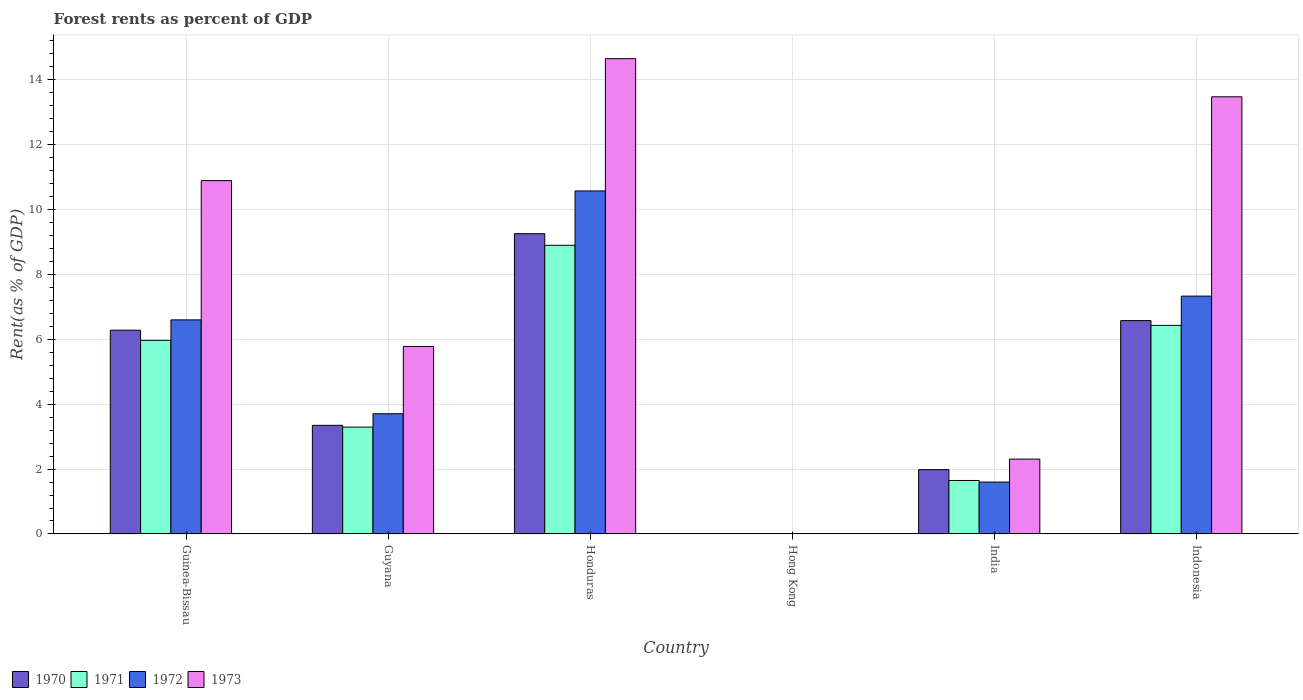How many different coloured bars are there?
Ensure brevity in your answer.  4. How many groups of bars are there?
Your answer should be very brief. 6. Are the number of bars per tick equal to the number of legend labels?
Ensure brevity in your answer.  Yes. How many bars are there on the 3rd tick from the right?
Provide a succinct answer. 4. What is the label of the 1st group of bars from the left?
Offer a terse response. Guinea-Bissau. In how many cases, is the number of bars for a given country not equal to the number of legend labels?
Keep it short and to the point. 0. What is the forest rent in 1973 in Honduras?
Ensure brevity in your answer.  14.64. Across all countries, what is the maximum forest rent in 1971?
Your answer should be very brief. 8.89. Across all countries, what is the minimum forest rent in 1970?
Offer a very short reply. 0.01. In which country was the forest rent in 1970 maximum?
Your response must be concise. Honduras. In which country was the forest rent in 1970 minimum?
Make the answer very short. Hong Kong. What is the total forest rent in 1970 in the graph?
Make the answer very short. 27.44. What is the difference between the forest rent in 1971 in Guinea-Bissau and that in Honduras?
Your response must be concise. -2.93. What is the difference between the forest rent in 1973 in Guyana and the forest rent in 1971 in Honduras?
Your answer should be very brief. -3.12. What is the average forest rent in 1970 per country?
Make the answer very short. 4.57. What is the difference between the forest rent of/in 1971 and forest rent of/in 1972 in Hong Kong?
Keep it short and to the point. 0. What is the ratio of the forest rent in 1972 in Guyana to that in India?
Make the answer very short. 2.32. Is the forest rent in 1970 in Honduras less than that in India?
Provide a succinct answer. No. Is the difference between the forest rent in 1971 in India and Indonesia greater than the difference between the forest rent in 1972 in India and Indonesia?
Keep it short and to the point. Yes. What is the difference between the highest and the second highest forest rent in 1973?
Provide a short and direct response. -2.58. What is the difference between the highest and the lowest forest rent in 1971?
Your answer should be very brief. 8.89. In how many countries, is the forest rent in 1970 greater than the average forest rent in 1970 taken over all countries?
Offer a very short reply. 3. Is it the case that in every country, the sum of the forest rent in 1972 and forest rent in 1970 is greater than the forest rent in 1971?
Your answer should be very brief. Yes. How many bars are there?
Provide a succinct answer. 24. Are all the bars in the graph horizontal?
Your response must be concise. No. How many countries are there in the graph?
Provide a short and direct response. 6. Are the values on the major ticks of Y-axis written in scientific E-notation?
Provide a succinct answer. No. Does the graph contain grids?
Offer a very short reply. Yes. How many legend labels are there?
Your response must be concise. 4. What is the title of the graph?
Offer a terse response. Forest rents as percent of GDP. Does "2010" appear as one of the legend labels in the graph?
Keep it short and to the point. No. What is the label or title of the Y-axis?
Your response must be concise. Rent(as % of GDP). What is the Rent(as % of GDP) in 1970 in Guinea-Bissau?
Your response must be concise. 6.28. What is the Rent(as % of GDP) in 1971 in Guinea-Bissau?
Give a very brief answer. 5.97. What is the Rent(as % of GDP) of 1972 in Guinea-Bissau?
Offer a very short reply. 6.6. What is the Rent(as % of GDP) in 1973 in Guinea-Bissau?
Make the answer very short. 10.89. What is the Rent(as % of GDP) in 1970 in Guyana?
Offer a terse response. 3.35. What is the Rent(as % of GDP) in 1971 in Guyana?
Offer a terse response. 3.29. What is the Rent(as % of GDP) in 1972 in Guyana?
Provide a succinct answer. 3.7. What is the Rent(as % of GDP) in 1973 in Guyana?
Provide a succinct answer. 5.78. What is the Rent(as % of GDP) of 1970 in Honduras?
Your answer should be very brief. 9.25. What is the Rent(as % of GDP) of 1971 in Honduras?
Offer a terse response. 8.89. What is the Rent(as % of GDP) in 1972 in Honduras?
Offer a terse response. 10.57. What is the Rent(as % of GDP) of 1973 in Honduras?
Ensure brevity in your answer.  14.64. What is the Rent(as % of GDP) of 1970 in Hong Kong?
Make the answer very short. 0.01. What is the Rent(as % of GDP) of 1971 in Hong Kong?
Your answer should be very brief. 0.01. What is the Rent(as % of GDP) in 1972 in Hong Kong?
Offer a very short reply. 0.01. What is the Rent(as % of GDP) of 1973 in Hong Kong?
Offer a very short reply. 0.01. What is the Rent(as % of GDP) in 1970 in India?
Ensure brevity in your answer.  1.98. What is the Rent(as % of GDP) of 1971 in India?
Provide a succinct answer. 1.65. What is the Rent(as % of GDP) of 1972 in India?
Provide a succinct answer. 1.6. What is the Rent(as % of GDP) in 1973 in India?
Your response must be concise. 2.31. What is the Rent(as % of GDP) of 1970 in Indonesia?
Your response must be concise. 6.57. What is the Rent(as % of GDP) in 1971 in Indonesia?
Offer a terse response. 6.43. What is the Rent(as % of GDP) of 1972 in Indonesia?
Offer a very short reply. 7.33. What is the Rent(as % of GDP) of 1973 in Indonesia?
Your answer should be very brief. 13.47. Across all countries, what is the maximum Rent(as % of GDP) in 1970?
Offer a terse response. 9.25. Across all countries, what is the maximum Rent(as % of GDP) of 1971?
Make the answer very short. 8.89. Across all countries, what is the maximum Rent(as % of GDP) of 1972?
Provide a succinct answer. 10.57. Across all countries, what is the maximum Rent(as % of GDP) of 1973?
Keep it short and to the point. 14.64. Across all countries, what is the minimum Rent(as % of GDP) in 1970?
Offer a terse response. 0.01. Across all countries, what is the minimum Rent(as % of GDP) of 1971?
Offer a very short reply. 0.01. Across all countries, what is the minimum Rent(as % of GDP) of 1972?
Your answer should be compact. 0.01. Across all countries, what is the minimum Rent(as % of GDP) of 1973?
Your answer should be very brief. 0.01. What is the total Rent(as % of GDP) in 1970 in the graph?
Offer a terse response. 27.44. What is the total Rent(as % of GDP) in 1971 in the graph?
Your response must be concise. 26.23. What is the total Rent(as % of GDP) of 1972 in the graph?
Your response must be concise. 29.8. What is the total Rent(as % of GDP) of 1973 in the graph?
Provide a succinct answer. 47.09. What is the difference between the Rent(as % of GDP) of 1970 in Guinea-Bissau and that in Guyana?
Keep it short and to the point. 2.93. What is the difference between the Rent(as % of GDP) of 1971 in Guinea-Bissau and that in Guyana?
Provide a short and direct response. 2.67. What is the difference between the Rent(as % of GDP) in 1972 in Guinea-Bissau and that in Guyana?
Provide a short and direct response. 2.89. What is the difference between the Rent(as % of GDP) of 1973 in Guinea-Bissau and that in Guyana?
Give a very brief answer. 5.11. What is the difference between the Rent(as % of GDP) of 1970 in Guinea-Bissau and that in Honduras?
Ensure brevity in your answer.  -2.97. What is the difference between the Rent(as % of GDP) in 1971 in Guinea-Bissau and that in Honduras?
Your response must be concise. -2.93. What is the difference between the Rent(as % of GDP) in 1972 in Guinea-Bissau and that in Honduras?
Offer a very short reply. -3.97. What is the difference between the Rent(as % of GDP) of 1973 in Guinea-Bissau and that in Honduras?
Your answer should be very brief. -3.76. What is the difference between the Rent(as % of GDP) of 1970 in Guinea-Bissau and that in Hong Kong?
Provide a succinct answer. 6.27. What is the difference between the Rent(as % of GDP) in 1971 in Guinea-Bissau and that in Hong Kong?
Offer a terse response. 5.96. What is the difference between the Rent(as % of GDP) of 1972 in Guinea-Bissau and that in Hong Kong?
Your response must be concise. 6.59. What is the difference between the Rent(as % of GDP) in 1973 in Guinea-Bissau and that in Hong Kong?
Offer a very short reply. 10.88. What is the difference between the Rent(as % of GDP) in 1970 in Guinea-Bissau and that in India?
Offer a very short reply. 4.3. What is the difference between the Rent(as % of GDP) of 1971 in Guinea-Bissau and that in India?
Your answer should be very brief. 4.32. What is the difference between the Rent(as % of GDP) in 1972 in Guinea-Bissau and that in India?
Offer a terse response. 5. What is the difference between the Rent(as % of GDP) in 1973 in Guinea-Bissau and that in India?
Your response must be concise. 8.58. What is the difference between the Rent(as % of GDP) in 1970 in Guinea-Bissau and that in Indonesia?
Your answer should be very brief. -0.3. What is the difference between the Rent(as % of GDP) in 1971 in Guinea-Bissau and that in Indonesia?
Provide a succinct answer. -0.46. What is the difference between the Rent(as % of GDP) of 1972 in Guinea-Bissau and that in Indonesia?
Offer a very short reply. -0.73. What is the difference between the Rent(as % of GDP) of 1973 in Guinea-Bissau and that in Indonesia?
Offer a very short reply. -2.58. What is the difference between the Rent(as % of GDP) in 1970 in Guyana and that in Honduras?
Provide a succinct answer. -5.9. What is the difference between the Rent(as % of GDP) of 1971 in Guyana and that in Honduras?
Keep it short and to the point. -5.6. What is the difference between the Rent(as % of GDP) of 1972 in Guyana and that in Honduras?
Keep it short and to the point. -6.86. What is the difference between the Rent(as % of GDP) of 1973 in Guyana and that in Honduras?
Ensure brevity in your answer.  -8.87. What is the difference between the Rent(as % of GDP) of 1970 in Guyana and that in Hong Kong?
Your answer should be compact. 3.34. What is the difference between the Rent(as % of GDP) of 1971 in Guyana and that in Hong Kong?
Offer a very short reply. 3.29. What is the difference between the Rent(as % of GDP) of 1972 in Guyana and that in Hong Kong?
Give a very brief answer. 3.7. What is the difference between the Rent(as % of GDP) in 1973 in Guyana and that in Hong Kong?
Provide a short and direct response. 5.77. What is the difference between the Rent(as % of GDP) of 1970 in Guyana and that in India?
Your answer should be compact. 1.37. What is the difference between the Rent(as % of GDP) in 1971 in Guyana and that in India?
Your answer should be compact. 1.64. What is the difference between the Rent(as % of GDP) in 1972 in Guyana and that in India?
Your answer should be compact. 2.11. What is the difference between the Rent(as % of GDP) in 1973 in Guyana and that in India?
Keep it short and to the point. 3.47. What is the difference between the Rent(as % of GDP) of 1970 in Guyana and that in Indonesia?
Ensure brevity in your answer.  -3.23. What is the difference between the Rent(as % of GDP) in 1971 in Guyana and that in Indonesia?
Your answer should be very brief. -3.13. What is the difference between the Rent(as % of GDP) of 1972 in Guyana and that in Indonesia?
Provide a succinct answer. -3.62. What is the difference between the Rent(as % of GDP) in 1973 in Guyana and that in Indonesia?
Make the answer very short. -7.69. What is the difference between the Rent(as % of GDP) of 1970 in Honduras and that in Hong Kong?
Your response must be concise. 9.24. What is the difference between the Rent(as % of GDP) in 1971 in Honduras and that in Hong Kong?
Provide a short and direct response. 8.89. What is the difference between the Rent(as % of GDP) of 1972 in Honduras and that in Hong Kong?
Provide a short and direct response. 10.56. What is the difference between the Rent(as % of GDP) in 1973 in Honduras and that in Hong Kong?
Your answer should be compact. 14.63. What is the difference between the Rent(as % of GDP) of 1970 in Honduras and that in India?
Provide a succinct answer. 7.27. What is the difference between the Rent(as % of GDP) of 1971 in Honduras and that in India?
Your answer should be very brief. 7.24. What is the difference between the Rent(as % of GDP) in 1972 in Honduras and that in India?
Your answer should be very brief. 8.97. What is the difference between the Rent(as % of GDP) of 1973 in Honduras and that in India?
Your answer should be very brief. 12.34. What is the difference between the Rent(as % of GDP) of 1970 in Honduras and that in Indonesia?
Your answer should be compact. 2.68. What is the difference between the Rent(as % of GDP) of 1971 in Honduras and that in Indonesia?
Keep it short and to the point. 2.47. What is the difference between the Rent(as % of GDP) of 1972 in Honduras and that in Indonesia?
Provide a succinct answer. 3.24. What is the difference between the Rent(as % of GDP) in 1973 in Honduras and that in Indonesia?
Ensure brevity in your answer.  1.18. What is the difference between the Rent(as % of GDP) of 1970 in Hong Kong and that in India?
Provide a short and direct response. -1.97. What is the difference between the Rent(as % of GDP) of 1971 in Hong Kong and that in India?
Your answer should be very brief. -1.64. What is the difference between the Rent(as % of GDP) of 1972 in Hong Kong and that in India?
Give a very brief answer. -1.59. What is the difference between the Rent(as % of GDP) in 1973 in Hong Kong and that in India?
Give a very brief answer. -2.3. What is the difference between the Rent(as % of GDP) in 1970 in Hong Kong and that in Indonesia?
Your answer should be very brief. -6.56. What is the difference between the Rent(as % of GDP) of 1971 in Hong Kong and that in Indonesia?
Your response must be concise. -6.42. What is the difference between the Rent(as % of GDP) in 1972 in Hong Kong and that in Indonesia?
Make the answer very short. -7.32. What is the difference between the Rent(as % of GDP) in 1973 in Hong Kong and that in Indonesia?
Give a very brief answer. -13.46. What is the difference between the Rent(as % of GDP) of 1970 in India and that in Indonesia?
Make the answer very short. -4.59. What is the difference between the Rent(as % of GDP) of 1971 in India and that in Indonesia?
Your answer should be compact. -4.78. What is the difference between the Rent(as % of GDP) in 1972 in India and that in Indonesia?
Keep it short and to the point. -5.73. What is the difference between the Rent(as % of GDP) in 1973 in India and that in Indonesia?
Provide a short and direct response. -11.16. What is the difference between the Rent(as % of GDP) in 1970 in Guinea-Bissau and the Rent(as % of GDP) in 1971 in Guyana?
Make the answer very short. 2.99. What is the difference between the Rent(as % of GDP) of 1970 in Guinea-Bissau and the Rent(as % of GDP) of 1972 in Guyana?
Your answer should be compact. 2.57. What is the difference between the Rent(as % of GDP) of 1970 in Guinea-Bissau and the Rent(as % of GDP) of 1973 in Guyana?
Ensure brevity in your answer.  0.5. What is the difference between the Rent(as % of GDP) of 1971 in Guinea-Bissau and the Rent(as % of GDP) of 1972 in Guyana?
Give a very brief answer. 2.26. What is the difference between the Rent(as % of GDP) of 1971 in Guinea-Bissau and the Rent(as % of GDP) of 1973 in Guyana?
Provide a short and direct response. 0.19. What is the difference between the Rent(as % of GDP) of 1972 in Guinea-Bissau and the Rent(as % of GDP) of 1973 in Guyana?
Ensure brevity in your answer.  0.82. What is the difference between the Rent(as % of GDP) in 1970 in Guinea-Bissau and the Rent(as % of GDP) in 1971 in Honduras?
Make the answer very short. -2.62. What is the difference between the Rent(as % of GDP) of 1970 in Guinea-Bissau and the Rent(as % of GDP) of 1972 in Honduras?
Provide a short and direct response. -4.29. What is the difference between the Rent(as % of GDP) in 1970 in Guinea-Bissau and the Rent(as % of GDP) in 1973 in Honduras?
Your response must be concise. -8.37. What is the difference between the Rent(as % of GDP) in 1971 in Guinea-Bissau and the Rent(as % of GDP) in 1972 in Honduras?
Provide a short and direct response. -4.6. What is the difference between the Rent(as % of GDP) in 1971 in Guinea-Bissau and the Rent(as % of GDP) in 1973 in Honduras?
Provide a short and direct response. -8.68. What is the difference between the Rent(as % of GDP) in 1972 in Guinea-Bissau and the Rent(as % of GDP) in 1973 in Honduras?
Your response must be concise. -8.05. What is the difference between the Rent(as % of GDP) of 1970 in Guinea-Bissau and the Rent(as % of GDP) of 1971 in Hong Kong?
Offer a very short reply. 6.27. What is the difference between the Rent(as % of GDP) of 1970 in Guinea-Bissau and the Rent(as % of GDP) of 1972 in Hong Kong?
Provide a succinct answer. 6.27. What is the difference between the Rent(as % of GDP) of 1970 in Guinea-Bissau and the Rent(as % of GDP) of 1973 in Hong Kong?
Your answer should be compact. 6.27. What is the difference between the Rent(as % of GDP) in 1971 in Guinea-Bissau and the Rent(as % of GDP) in 1972 in Hong Kong?
Make the answer very short. 5.96. What is the difference between the Rent(as % of GDP) in 1971 in Guinea-Bissau and the Rent(as % of GDP) in 1973 in Hong Kong?
Offer a terse response. 5.95. What is the difference between the Rent(as % of GDP) of 1972 in Guinea-Bissau and the Rent(as % of GDP) of 1973 in Hong Kong?
Ensure brevity in your answer.  6.58. What is the difference between the Rent(as % of GDP) of 1970 in Guinea-Bissau and the Rent(as % of GDP) of 1971 in India?
Your answer should be compact. 4.63. What is the difference between the Rent(as % of GDP) of 1970 in Guinea-Bissau and the Rent(as % of GDP) of 1972 in India?
Your answer should be compact. 4.68. What is the difference between the Rent(as % of GDP) of 1970 in Guinea-Bissau and the Rent(as % of GDP) of 1973 in India?
Keep it short and to the point. 3.97. What is the difference between the Rent(as % of GDP) of 1971 in Guinea-Bissau and the Rent(as % of GDP) of 1972 in India?
Provide a succinct answer. 4.37. What is the difference between the Rent(as % of GDP) of 1971 in Guinea-Bissau and the Rent(as % of GDP) of 1973 in India?
Keep it short and to the point. 3.66. What is the difference between the Rent(as % of GDP) in 1972 in Guinea-Bissau and the Rent(as % of GDP) in 1973 in India?
Make the answer very short. 4.29. What is the difference between the Rent(as % of GDP) of 1970 in Guinea-Bissau and the Rent(as % of GDP) of 1971 in Indonesia?
Your answer should be very brief. -0.15. What is the difference between the Rent(as % of GDP) of 1970 in Guinea-Bissau and the Rent(as % of GDP) of 1972 in Indonesia?
Provide a succinct answer. -1.05. What is the difference between the Rent(as % of GDP) of 1970 in Guinea-Bissau and the Rent(as % of GDP) of 1973 in Indonesia?
Provide a succinct answer. -7.19. What is the difference between the Rent(as % of GDP) in 1971 in Guinea-Bissau and the Rent(as % of GDP) in 1972 in Indonesia?
Provide a short and direct response. -1.36. What is the difference between the Rent(as % of GDP) in 1971 in Guinea-Bissau and the Rent(as % of GDP) in 1973 in Indonesia?
Your answer should be very brief. -7.5. What is the difference between the Rent(as % of GDP) in 1972 in Guinea-Bissau and the Rent(as % of GDP) in 1973 in Indonesia?
Offer a very short reply. -6.87. What is the difference between the Rent(as % of GDP) in 1970 in Guyana and the Rent(as % of GDP) in 1971 in Honduras?
Keep it short and to the point. -5.55. What is the difference between the Rent(as % of GDP) in 1970 in Guyana and the Rent(as % of GDP) in 1972 in Honduras?
Make the answer very short. -7.22. What is the difference between the Rent(as % of GDP) of 1970 in Guyana and the Rent(as % of GDP) of 1973 in Honduras?
Provide a short and direct response. -11.3. What is the difference between the Rent(as % of GDP) of 1971 in Guyana and the Rent(as % of GDP) of 1972 in Honduras?
Keep it short and to the point. -7.28. What is the difference between the Rent(as % of GDP) of 1971 in Guyana and the Rent(as % of GDP) of 1973 in Honduras?
Your answer should be compact. -11.35. What is the difference between the Rent(as % of GDP) in 1972 in Guyana and the Rent(as % of GDP) in 1973 in Honduras?
Offer a terse response. -10.94. What is the difference between the Rent(as % of GDP) in 1970 in Guyana and the Rent(as % of GDP) in 1971 in Hong Kong?
Make the answer very short. 3.34. What is the difference between the Rent(as % of GDP) of 1970 in Guyana and the Rent(as % of GDP) of 1972 in Hong Kong?
Offer a terse response. 3.34. What is the difference between the Rent(as % of GDP) of 1970 in Guyana and the Rent(as % of GDP) of 1973 in Hong Kong?
Make the answer very short. 3.34. What is the difference between the Rent(as % of GDP) of 1971 in Guyana and the Rent(as % of GDP) of 1972 in Hong Kong?
Keep it short and to the point. 3.29. What is the difference between the Rent(as % of GDP) of 1971 in Guyana and the Rent(as % of GDP) of 1973 in Hong Kong?
Offer a very short reply. 3.28. What is the difference between the Rent(as % of GDP) in 1972 in Guyana and the Rent(as % of GDP) in 1973 in Hong Kong?
Offer a terse response. 3.69. What is the difference between the Rent(as % of GDP) of 1970 in Guyana and the Rent(as % of GDP) of 1971 in India?
Give a very brief answer. 1.7. What is the difference between the Rent(as % of GDP) of 1970 in Guyana and the Rent(as % of GDP) of 1972 in India?
Your response must be concise. 1.75. What is the difference between the Rent(as % of GDP) of 1970 in Guyana and the Rent(as % of GDP) of 1973 in India?
Provide a succinct answer. 1.04. What is the difference between the Rent(as % of GDP) in 1971 in Guyana and the Rent(as % of GDP) in 1972 in India?
Your answer should be compact. 1.69. What is the difference between the Rent(as % of GDP) in 1972 in Guyana and the Rent(as % of GDP) in 1973 in India?
Your answer should be very brief. 1.4. What is the difference between the Rent(as % of GDP) in 1970 in Guyana and the Rent(as % of GDP) in 1971 in Indonesia?
Your answer should be very brief. -3.08. What is the difference between the Rent(as % of GDP) of 1970 in Guyana and the Rent(as % of GDP) of 1972 in Indonesia?
Make the answer very short. -3.98. What is the difference between the Rent(as % of GDP) of 1970 in Guyana and the Rent(as % of GDP) of 1973 in Indonesia?
Your answer should be compact. -10.12. What is the difference between the Rent(as % of GDP) in 1971 in Guyana and the Rent(as % of GDP) in 1972 in Indonesia?
Your response must be concise. -4.04. What is the difference between the Rent(as % of GDP) of 1971 in Guyana and the Rent(as % of GDP) of 1973 in Indonesia?
Make the answer very short. -10.18. What is the difference between the Rent(as % of GDP) in 1972 in Guyana and the Rent(as % of GDP) in 1973 in Indonesia?
Your answer should be very brief. -9.76. What is the difference between the Rent(as % of GDP) in 1970 in Honduras and the Rent(as % of GDP) in 1971 in Hong Kong?
Your answer should be very brief. 9.25. What is the difference between the Rent(as % of GDP) in 1970 in Honduras and the Rent(as % of GDP) in 1972 in Hong Kong?
Keep it short and to the point. 9.25. What is the difference between the Rent(as % of GDP) of 1970 in Honduras and the Rent(as % of GDP) of 1973 in Hong Kong?
Offer a terse response. 9.24. What is the difference between the Rent(as % of GDP) in 1971 in Honduras and the Rent(as % of GDP) in 1972 in Hong Kong?
Your answer should be compact. 8.89. What is the difference between the Rent(as % of GDP) in 1971 in Honduras and the Rent(as % of GDP) in 1973 in Hong Kong?
Ensure brevity in your answer.  8.88. What is the difference between the Rent(as % of GDP) in 1972 in Honduras and the Rent(as % of GDP) in 1973 in Hong Kong?
Offer a very short reply. 10.56. What is the difference between the Rent(as % of GDP) of 1970 in Honduras and the Rent(as % of GDP) of 1971 in India?
Provide a succinct answer. 7.6. What is the difference between the Rent(as % of GDP) of 1970 in Honduras and the Rent(as % of GDP) of 1972 in India?
Your response must be concise. 7.65. What is the difference between the Rent(as % of GDP) of 1970 in Honduras and the Rent(as % of GDP) of 1973 in India?
Offer a very short reply. 6.95. What is the difference between the Rent(as % of GDP) of 1971 in Honduras and the Rent(as % of GDP) of 1972 in India?
Provide a succinct answer. 7.29. What is the difference between the Rent(as % of GDP) of 1971 in Honduras and the Rent(as % of GDP) of 1973 in India?
Your answer should be very brief. 6.59. What is the difference between the Rent(as % of GDP) of 1972 in Honduras and the Rent(as % of GDP) of 1973 in India?
Provide a short and direct response. 8.26. What is the difference between the Rent(as % of GDP) in 1970 in Honduras and the Rent(as % of GDP) in 1971 in Indonesia?
Give a very brief answer. 2.83. What is the difference between the Rent(as % of GDP) in 1970 in Honduras and the Rent(as % of GDP) in 1972 in Indonesia?
Your response must be concise. 1.92. What is the difference between the Rent(as % of GDP) of 1970 in Honduras and the Rent(as % of GDP) of 1973 in Indonesia?
Offer a very short reply. -4.22. What is the difference between the Rent(as % of GDP) of 1971 in Honduras and the Rent(as % of GDP) of 1972 in Indonesia?
Your answer should be very brief. 1.57. What is the difference between the Rent(as % of GDP) in 1971 in Honduras and the Rent(as % of GDP) in 1973 in Indonesia?
Your answer should be very brief. -4.57. What is the difference between the Rent(as % of GDP) in 1972 in Honduras and the Rent(as % of GDP) in 1973 in Indonesia?
Offer a terse response. -2.9. What is the difference between the Rent(as % of GDP) in 1970 in Hong Kong and the Rent(as % of GDP) in 1971 in India?
Make the answer very short. -1.64. What is the difference between the Rent(as % of GDP) of 1970 in Hong Kong and the Rent(as % of GDP) of 1972 in India?
Make the answer very short. -1.59. What is the difference between the Rent(as % of GDP) in 1970 in Hong Kong and the Rent(as % of GDP) in 1973 in India?
Provide a succinct answer. -2.3. What is the difference between the Rent(as % of GDP) of 1971 in Hong Kong and the Rent(as % of GDP) of 1972 in India?
Give a very brief answer. -1.59. What is the difference between the Rent(as % of GDP) of 1971 in Hong Kong and the Rent(as % of GDP) of 1973 in India?
Offer a very short reply. -2.3. What is the difference between the Rent(as % of GDP) of 1972 in Hong Kong and the Rent(as % of GDP) of 1973 in India?
Your response must be concise. -2.3. What is the difference between the Rent(as % of GDP) of 1970 in Hong Kong and the Rent(as % of GDP) of 1971 in Indonesia?
Give a very brief answer. -6.42. What is the difference between the Rent(as % of GDP) of 1970 in Hong Kong and the Rent(as % of GDP) of 1972 in Indonesia?
Your answer should be very brief. -7.32. What is the difference between the Rent(as % of GDP) in 1970 in Hong Kong and the Rent(as % of GDP) in 1973 in Indonesia?
Your response must be concise. -13.46. What is the difference between the Rent(as % of GDP) in 1971 in Hong Kong and the Rent(as % of GDP) in 1972 in Indonesia?
Offer a terse response. -7.32. What is the difference between the Rent(as % of GDP) in 1971 in Hong Kong and the Rent(as % of GDP) in 1973 in Indonesia?
Keep it short and to the point. -13.46. What is the difference between the Rent(as % of GDP) of 1972 in Hong Kong and the Rent(as % of GDP) of 1973 in Indonesia?
Your response must be concise. -13.46. What is the difference between the Rent(as % of GDP) of 1970 in India and the Rent(as % of GDP) of 1971 in Indonesia?
Your answer should be compact. -4.44. What is the difference between the Rent(as % of GDP) of 1970 in India and the Rent(as % of GDP) of 1972 in Indonesia?
Offer a very short reply. -5.35. What is the difference between the Rent(as % of GDP) of 1970 in India and the Rent(as % of GDP) of 1973 in Indonesia?
Offer a very short reply. -11.49. What is the difference between the Rent(as % of GDP) of 1971 in India and the Rent(as % of GDP) of 1972 in Indonesia?
Make the answer very short. -5.68. What is the difference between the Rent(as % of GDP) of 1971 in India and the Rent(as % of GDP) of 1973 in Indonesia?
Make the answer very short. -11.82. What is the difference between the Rent(as % of GDP) of 1972 in India and the Rent(as % of GDP) of 1973 in Indonesia?
Give a very brief answer. -11.87. What is the average Rent(as % of GDP) in 1970 per country?
Make the answer very short. 4.57. What is the average Rent(as % of GDP) of 1971 per country?
Keep it short and to the point. 4.37. What is the average Rent(as % of GDP) in 1972 per country?
Your answer should be compact. 4.97. What is the average Rent(as % of GDP) in 1973 per country?
Ensure brevity in your answer.  7.85. What is the difference between the Rent(as % of GDP) of 1970 and Rent(as % of GDP) of 1971 in Guinea-Bissau?
Your response must be concise. 0.31. What is the difference between the Rent(as % of GDP) of 1970 and Rent(as % of GDP) of 1972 in Guinea-Bissau?
Provide a succinct answer. -0.32. What is the difference between the Rent(as % of GDP) of 1970 and Rent(as % of GDP) of 1973 in Guinea-Bissau?
Provide a succinct answer. -4.61. What is the difference between the Rent(as % of GDP) of 1971 and Rent(as % of GDP) of 1972 in Guinea-Bissau?
Give a very brief answer. -0.63. What is the difference between the Rent(as % of GDP) in 1971 and Rent(as % of GDP) in 1973 in Guinea-Bissau?
Offer a terse response. -4.92. What is the difference between the Rent(as % of GDP) in 1972 and Rent(as % of GDP) in 1973 in Guinea-Bissau?
Keep it short and to the point. -4.29. What is the difference between the Rent(as % of GDP) of 1970 and Rent(as % of GDP) of 1971 in Guyana?
Provide a short and direct response. 0.05. What is the difference between the Rent(as % of GDP) of 1970 and Rent(as % of GDP) of 1972 in Guyana?
Your response must be concise. -0.36. What is the difference between the Rent(as % of GDP) in 1970 and Rent(as % of GDP) in 1973 in Guyana?
Offer a terse response. -2.43. What is the difference between the Rent(as % of GDP) in 1971 and Rent(as % of GDP) in 1972 in Guyana?
Ensure brevity in your answer.  -0.41. What is the difference between the Rent(as % of GDP) in 1971 and Rent(as % of GDP) in 1973 in Guyana?
Make the answer very short. -2.48. What is the difference between the Rent(as % of GDP) in 1972 and Rent(as % of GDP) in 1973 in Guyana?
Give a very brief answer. -2.07. What is the difference between the Rent(as % of GDP) in 1970 and Rent(as % of GDP) in 1971 in Honduras?
Offer a very short reply. 0.36. What is the difference between the Rent(as % of GDP) of 1970 and Rent(as % of GDP) of 1972 in Honduras?
Provide a succinct answer. -1.32. What is the difference between the Rent(as % of GDP) in 1970 and Rent(as % of GDP) in 1973 in Honduras?
Provide a succinct answer. -5.39. What is the difference between the Rent(as % of GDP) of 1971 and Rent(as % of GDP) of 1972 in Honduras?
Your answer should be very brief. -1.67. What is the difference between the Rent(as % of GDP) in 1971 and Rent(as % of GDP) in 1973 in Honduras?
Offer a very short reply. -5.75. What is the difference between the Rent(as % of GDP) in 1972 and Rent(as % of GDP) in 1973 in Honduras?
Ensure brevity in your answer.  -4.08. What is the difference between the Rent(as % of GDP) of 1970 and Rent(as % of GDP) of 1971 in Hong Kong?
Ensure brevity in your answer.  0. What is the difference between the Rent(as % of GDP) of 1970 and Rent(as % of GDP) of 1972 in Hong Kong?
Ensure brevity in your answer.  0. What is the difference between the Rent(as % of GDP) of 1970 and Rent(as % of GDP) of 1973 in Hong Kong?
Give a very brief answer. -0. What is the difference between the Rent(as % of GDP) in 1971 and Rent(as % of GDP) in 1973 in Hong Kong?
Offer a terse response. -0. What is the difference between the Rent(as % of GDP) of 1972 and Rent(as % of GDP) of 1973 in Hong Kong?
Provide a succinct answer. -0. What is the difference between the Rent(as % of GDP) of 1970 and Rent(as % of GDP) of 1971 in India?
Keep it short and to the point. 0.33. What is the difference between the Rent(as % of GDP) of 1970 and Rent(as % of GDP) of 1972 in India?
Your answer should be very brief. 0.38. What is the difference between the Rent(as % of GDP) of 1970 and Rent(as % of GDP) of 1973 in India?
Offer a terse response. -0.32. What is the difference between the Rent(as % of GDP) of 1971 and Rent(as % of GDP) of 1972 in India?
Provide a succinct answer. 0.05. What is the difference between the Rent(as % of GDP) of 1971 and Rent(as % of GDP) of 1973 in India?
Give a very brief answer. -0.66. What is the difference between the Rent(as % of GDP) in 1972 and Rent(as % of GDP) in 1973 in India?
Provide a succinct answer. -0.71. What is the difference between the Rent(as % of GDP) in 1970 and Rent(as % of GDP) in 1971 in Indonesia?
Offer a terse response. 0.15. What is the difference between the Rent(as % of GDP) in 1970 and Rent(as % of GDP) in 1972 in Indonesia?
Your response must be concise. -0.75. What is the difference between the Rent(as % of GDP) in 1970 and Rent(as % of GDP) in 1973 in Indonesia?
Offer a very short reply. -6.89. What is the difference between the Rent(as % of GDP) of 1971 and Rent(as % of GDP) of 1972 in Indonesia?
Offer a very short reply. -0.9. What is the difference between the Rent(as % of GDP) of 1971 and Rent(as % of GDP) of 1973 in Indonesia?
Provide a succinct answer. -7.04. What is the difference between the Rent(as % of GDP) of 1972 and Rent(as % of GDP) of 1973 in Indonesia?
Provide a succinct answer. -6.14. What is the ratio of the Rent(as % of GDP) in 1970 in Guinea-Bissau to that in Guyana?
Your response must be concise. 1.88. What is the ratio of the Rent(as % of GDP) of 1971 in Guinea-Bissau to that in Guyana?
Your answer should be very brief. 1.81. What is the ratio of the Rent(as % of GDP) of 1972 in Guinea-Bissau to that in Guyana?
Ensure brevity in your answer.  1.78. What is the ratio of the Rent(as % of GDP) of 1973 in Guinea-Bissau to that in Guyana?
Give a very brief answer. 1.88. What is the ratio of the Rent(as % of GDP) of 1970 in Guinea-Bissau to that in Honduras?
Your answer should be compact. 0.68. What is the ratio of the Rent(as % of GDP) of 1971 in Guinea-Bissau to that in Honduras?
Give a very brief answer. 0.67. What is the ratio of the Rent(as % of GDP) of 1972 in Guinea-Bissau to that in Honduras?
Your answer should be very brief. 0.62. What is the ratio of the Rent(as % of GDP) in 1973 in Guinea-Bissau to that in Honduras?
Provide a short and direct response. 0.74. What is the ratio of the Rent(as % of GDP) of 1970 in Guinea-Bissau to that in Hong Kong?
Your answer should be compact. 639.74. What is the ratio of the Rent(as % of GDP) of 1971 in Guinea-Bissau to that in Hong Kong?
Offer a very short reply. 907.52. What is the ratio of the Rent(as % of GDP) of 1972 in Guinea-Bissau to that in Hong Kong?
Offer a very short reply. 1022.94. What is the ratio of the Rent(as % of GDP) in 1973 in Guinea-Bissau to that in Hong Kong?
Provide a succinct answer. 1008.57. What is the ratio of the Rent(as % of GDP) of 1970 in Guinea-Bissau to that in India?
Offer a terse response. 3.17. What is the ratio of the Rent(as % of GDP) of 1971 in Guinea-Bissau to that in India?
Provide a succinct answer. 3.62. What is the ratio of the Rent(as % of GDP) in 1972 in Guinea-Bissau to that in India?
Keep it short and to the point. 4.12. What is the ratio of the Rent(as % of GDP) of 1973 in Guinea-Bissau to that in India?
Your response must be concise. 4.72. What is the ratio of the Rent(as % of GDP) in 1970 in Guinea-Bissau to that in Indonesia?
Offer a very short reply. 0.95. What is the ratio of the Rent(as % of GDP) in 1971 in Guinea-Bissau to that in Indonesia?
Your answer should be compact. 0.93. What is the ratio of the Rent(as % of GDP) of 1973 in Guinea-Bissau to that in Indonesia?
Your response must be concise. 0.81. What is the ratio of the Rent(as % of GDP) of 1970 in Guyana to that in Honduras?
Ensure brevity in your answer.  0.36. What is the ratio of the Rent(as % of GDP) of 1971 in Guyana to that in Honduras?
Provide a short and direct response. 0.37. What is the ratio of the Rent(as % of GDP) of 1972 in Guyana to that in Honduras?
Offer a terse response. 0.35. What is the ratio of the Rent(as % of GDP) of 1973 in Guyana to that in Honduras?
Offer a terse response. 0.39. What is the ratio of the Rent(as % of GDP) in 1970 in Guyana to that in Hong Kong?
Make the answer very short. 341.1. What is the ratio of the Rent(as % of GDP) of 1971 in Guyana to that in Hong Kong?
Offer a very short reply. 500.92. What is the ratio of the Rent(as % of GDP) in 1972 in Guyana to that in Hong Kong?
Offer a terse response. 574.53. What is the ratio of the Rent(as % of GDP) in 1973 in Guyana to that in Hong Kong?
Your answer should be very brief. 535.14. What is the ratio of the Rent(as % of GDP) in 1970 in Guyana to that in India?
Provide a short and direct response. 1.69. What is the ratio of the Rent(as % of GDP) in 1971 in Guyana to that in India?
Your answer should be very brief. 2. What is the ratio of the Rent(as % of GDP) of 1972 in Guyana to that in India?
Provide a short and direct response. 2.32. What is the ratio of the Rent(as % of GDP) of 1973 in Guyana to that in India?
Make the answer very short. 2.5. What is the ratio of the Rent(as % of GDP) of 1970 in Guyana to that in Indonesia?
Your answer should be compact. 0.51. What is the ratio of the Rent(as % of GDP) in 1971 in Guyana to that in Indonesia?
Your answer should be very brief. 0.51. What is the ratio of the Rent(as % of GDP) of 1972 in Guyana to that in Indonesia?
Your response must be concise. 0.51. What is the ratio of the Rent(as % of GDP) in 1973 in Guyana to that in Indonesia?
Your answer should be very brief. 0.43. What is the ratio of the Rent(as % of GDP) in 1970 in Honduras to that in Hong Kong?
Offer a terse response. 942.83. What is the ratio of the Rent(as % of GDP) of 1971 in Honduras to that in Hong Kong?
Ensure brevity in your answer.  1352.94. What is the ratio of the Rent(as % of GDP) in 1972 in Honduras to that in Hong Kong?
Ensure brevity in your answer.  1639.07. What is the ratio of the Rent(as % of GDP) of 1973 in Honduras to that in Hong Kong?
Your response must be concise. 1356.64. What is the ratio of the Rent(as % of GDP) of 1970 in Honduras to that in India?
Your answer should be very brief. 4.67. What is the ratio of the Rent(as % of GDP) in 1971 in Honduras to that in India?
Offer a terse response. 5.4. What is the ratio of the Rent(as % of GDP) of 1972 in Honduras to that in India?
Provide a short and direct response. 6.61. What is the ratio of the Rent(as % of GDP) of 1973 in Honduras to that in India?
Offer a terse response. 6.35. What is the ratio of the Rent(as % of GDP) of 1970 in Honduras to that in Indonesia?
Make the answer very short. 1.41. What is the ratio of the Rent(as % of GDP) in 1971 in Honduras to that in Indonesia?
Keep it short and to the point. 1.38. What is the ratio of the Rent(as % of GDP) in 1972 in Honduras to that in Indonesia?
Your response must be concise. 1.44. What is the ratio of the Rent(as % of GDP) in 1973 in Honduras to that in Indonesia?
Ensure brevity in your answer.  1.09. What is the ratio of the Rent(as % of GDP) in 1970 in Hong Kong to that in India?
Your response must be concise. 0.01. What is the ratio of the Rent(as % of GDP) of 1971 in Hong Kong to that in India?
Your answer should be compact. 0. What is the ratio of the Rent(as % of GDP) of 1972 in Hong Kong to that in India?
Your answer should be compact. 0. What is the ratio of the Rent(as % of GDP) in 1973 in Hong Kong to that in India?
Make the answer very short. 0. What is the ratio of the Rent(as % of GDP) in 1970 in Hong Kong to that in Indonesia?
Give a very brief answer. 0. What is the ratio of the Rent(as % of GDP) of 1971 in Hong Kong to that in Indonesia?
Offer a very short reply. 0. What is the ratio of the Rent(as % of GDP) in 1972 in Hong Kong to that in Indonesia?
Offer a very short reply. 0. What is the ratio of the Rent(as % of GDP) of 1973 in Hong Kong to that in Indonesia?
Your response must be concise. 0. What is the ratio of the Rent(as % of GDP) of 1970 in India to that in Indonesia?
Provide a succinct answer. 0.3. What is the ratio of the Rent(as % of GDP) in 1971 in India to that in Indonesia?
Keep it short and to the point. 0.26. What is the ratio of the Rent(as % of GDP) in 1972 in India to that in Indonesia?
Your answer should be compact. 0.22. What is the ratio of the Rent(as % of GDP) of 1973 in India to that in Indonesia?
Keep it short and to the point. 0.17. What is the difference between the highest and the second highest Rent(as % of GDP) of 1970?
Provide a succinct answer. 2.68. What is the difference between the highest and the second highest Rent(as % of GDP) in 1971?
Provide a succinct answer. 2.47. What is the difference between the highest and the second highest Rent(as % of GDP) in 1972?
Your answer should be compact. 3.24. What is the difference between the highest and the second highest Rent(as % of GDP) in 1973?
Offer a very short reply. 1.18. What is the difference between the highest and the lowest Rent(as % of GDP) of 1970?
Your response must be concise. 9.24. What is the difference between the highest and the lowest Rent(as % of GDP) in 1971?
Keep it short and to the point. 8.89. What is the difference between the highest and the lowest Rent(as % of GDP) in 1972?
Your answer should be very brief. 10.56. What is the difference between the highest and the lowest Rent(as % of GDP) of 1973?
Give a very brief answer. 14.63. 